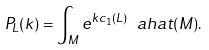<formula> <loc_0><loc_0><loc_500><loc_500>P _ { L } ( k ) = \int _ { M } e ^ { k c _ { 1 } ( L ) } \ a h a t ( M ) .</formula> 